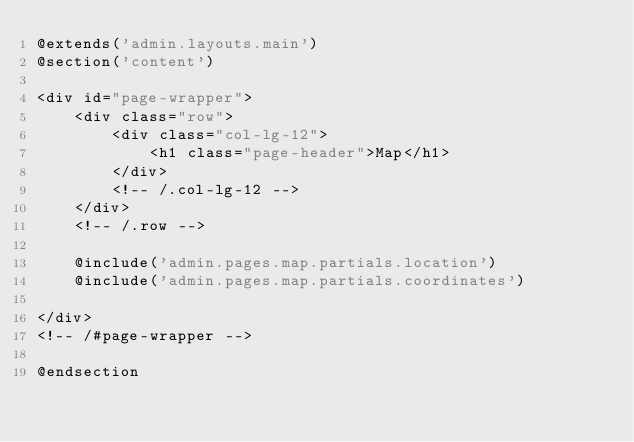Convert code to text. <code><loc_0><loc_0><loc_500><loc_500><_PHP_>@extends('admin.layouts.main')
@section('content')

<div id="page-wrapper">
    <div class="row">
        <div class="col-lg-12">
            <h1 class="page-header">Map</h1>
        </div>
        <!-- /.col-lg-12 -->
    </div>
    <!-- /.row -->
     
    @include('admin.pages.map.partials.location')
    @include('admin.pages.map.partials.coordinates')

</div>
<!-- /#page-wrapper -->

@endsection

</code> 